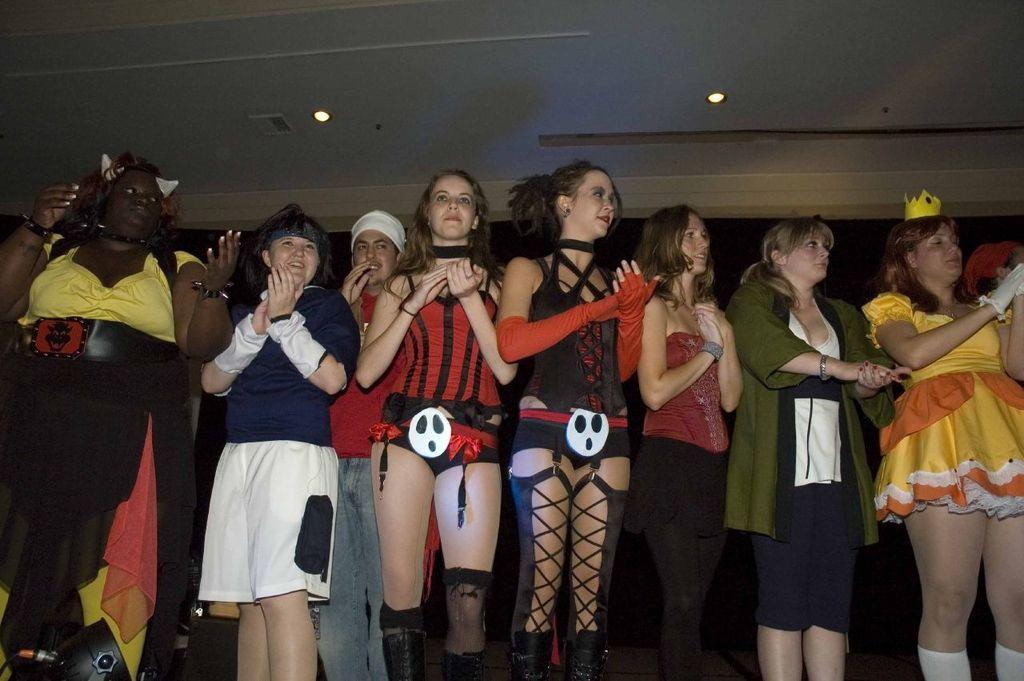What are the people in the image doing? People are clapping their hands in the image. What can be seen on the ceiling in the image? Lights are attached to the ceiling in the image. What type of beds can be seen in the image? There are no beds present in the image. What kind of lunch is being served in the image? There is no lunch being served in the image. 